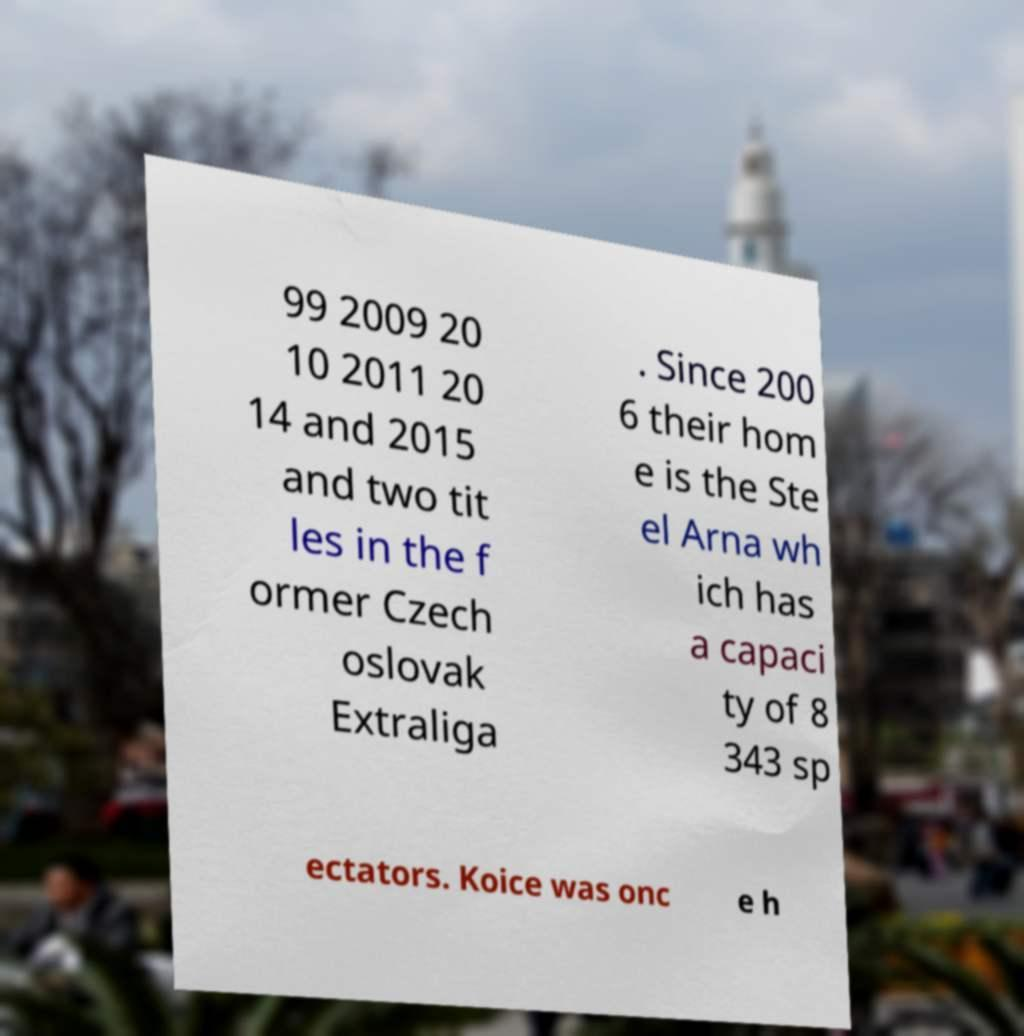There's text embedded in this image that I need extracted. Can you transcribe it verbatim? 99 2009 20 10 2011 20 14 and 2015 and two tit les in the f ormer Czech oslovak Extraliga . Since 200 6 their hom e is the Ste el Arna wh ich has a capaci ty of 8 343 sp ectators. Koice was onc e h 